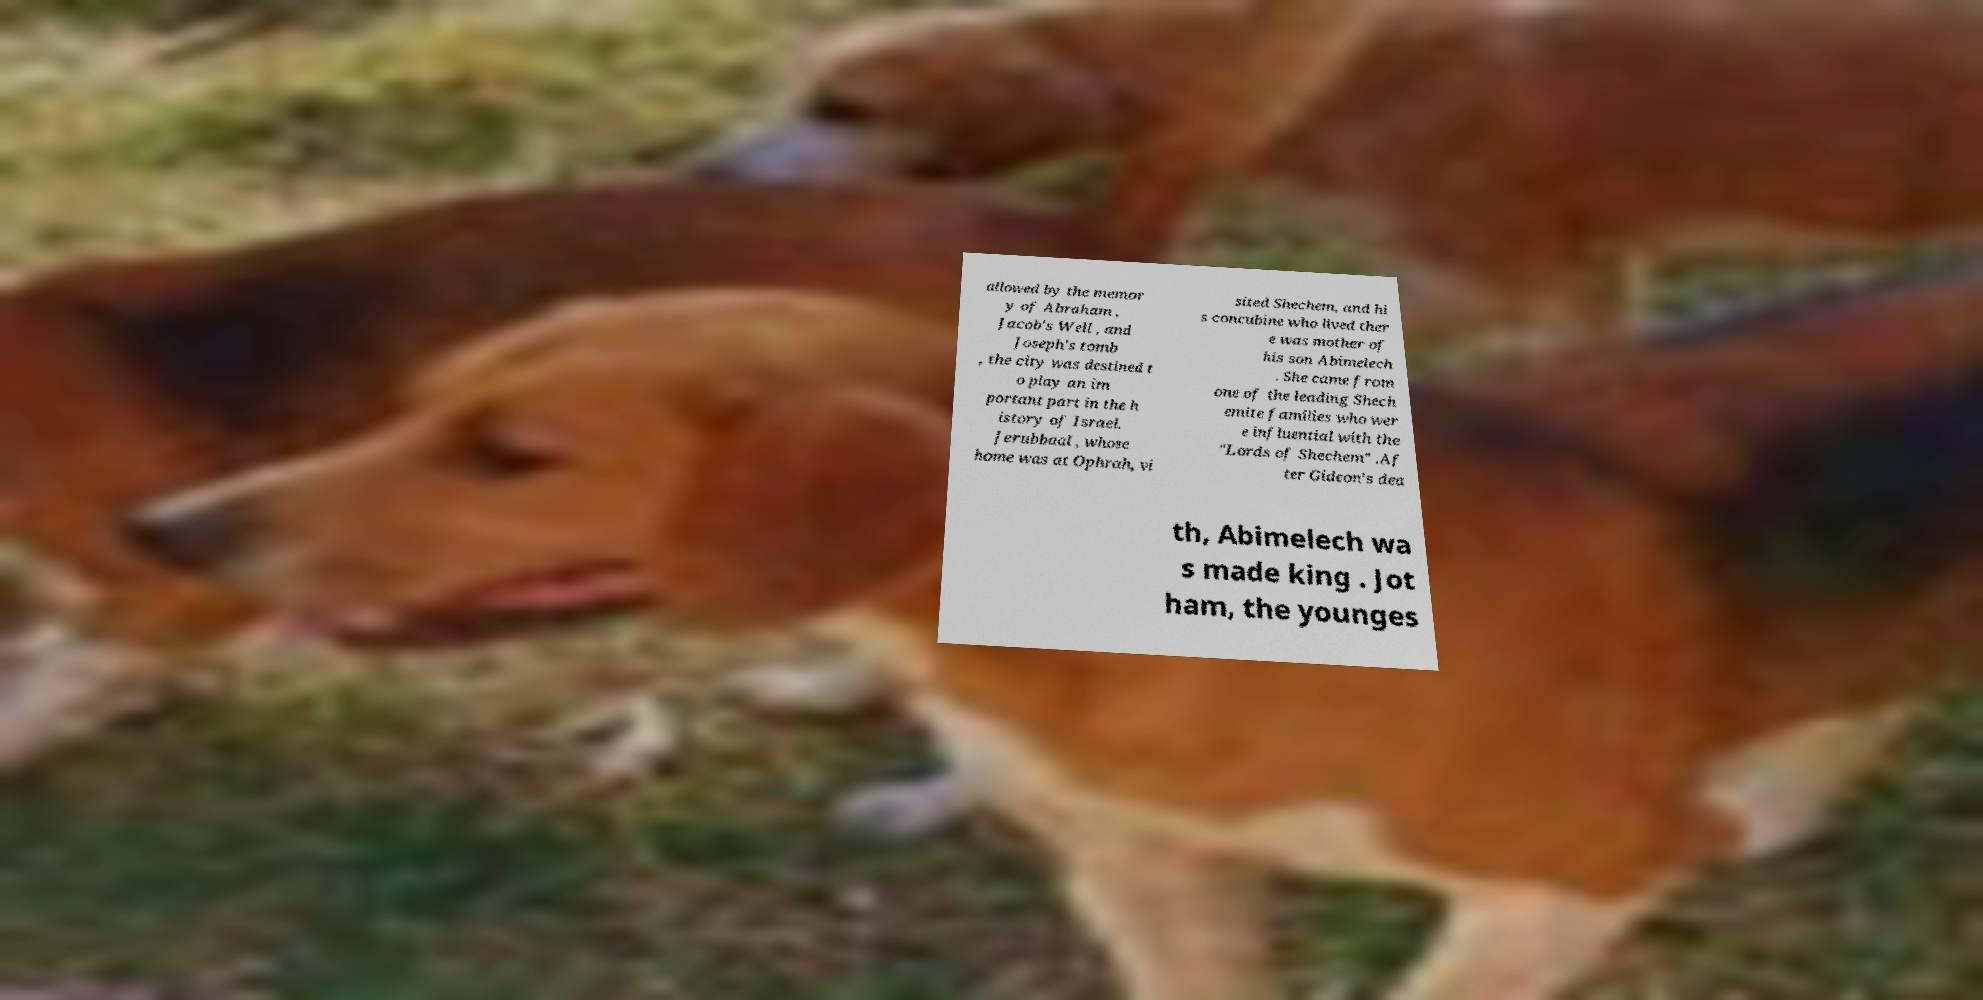Can you accurately transcribe the text from the provided image for me? allowed by the memor y of Abraham , Jacob's Well , and Joseph's tomb , the city was destined t o play an im portant part in the h istory of Israel. Jerubbaal , whose home was at Ophrah, vi sited Shechem, and hi s concubine who lived ther e was mother of his son Abimelech . She came from one of the leading Shech emite families who wer e influential with the "Lords of Shechem" .Af ter Gideon's dea th, Abimelech wa s made king . Jot ham, the younges 